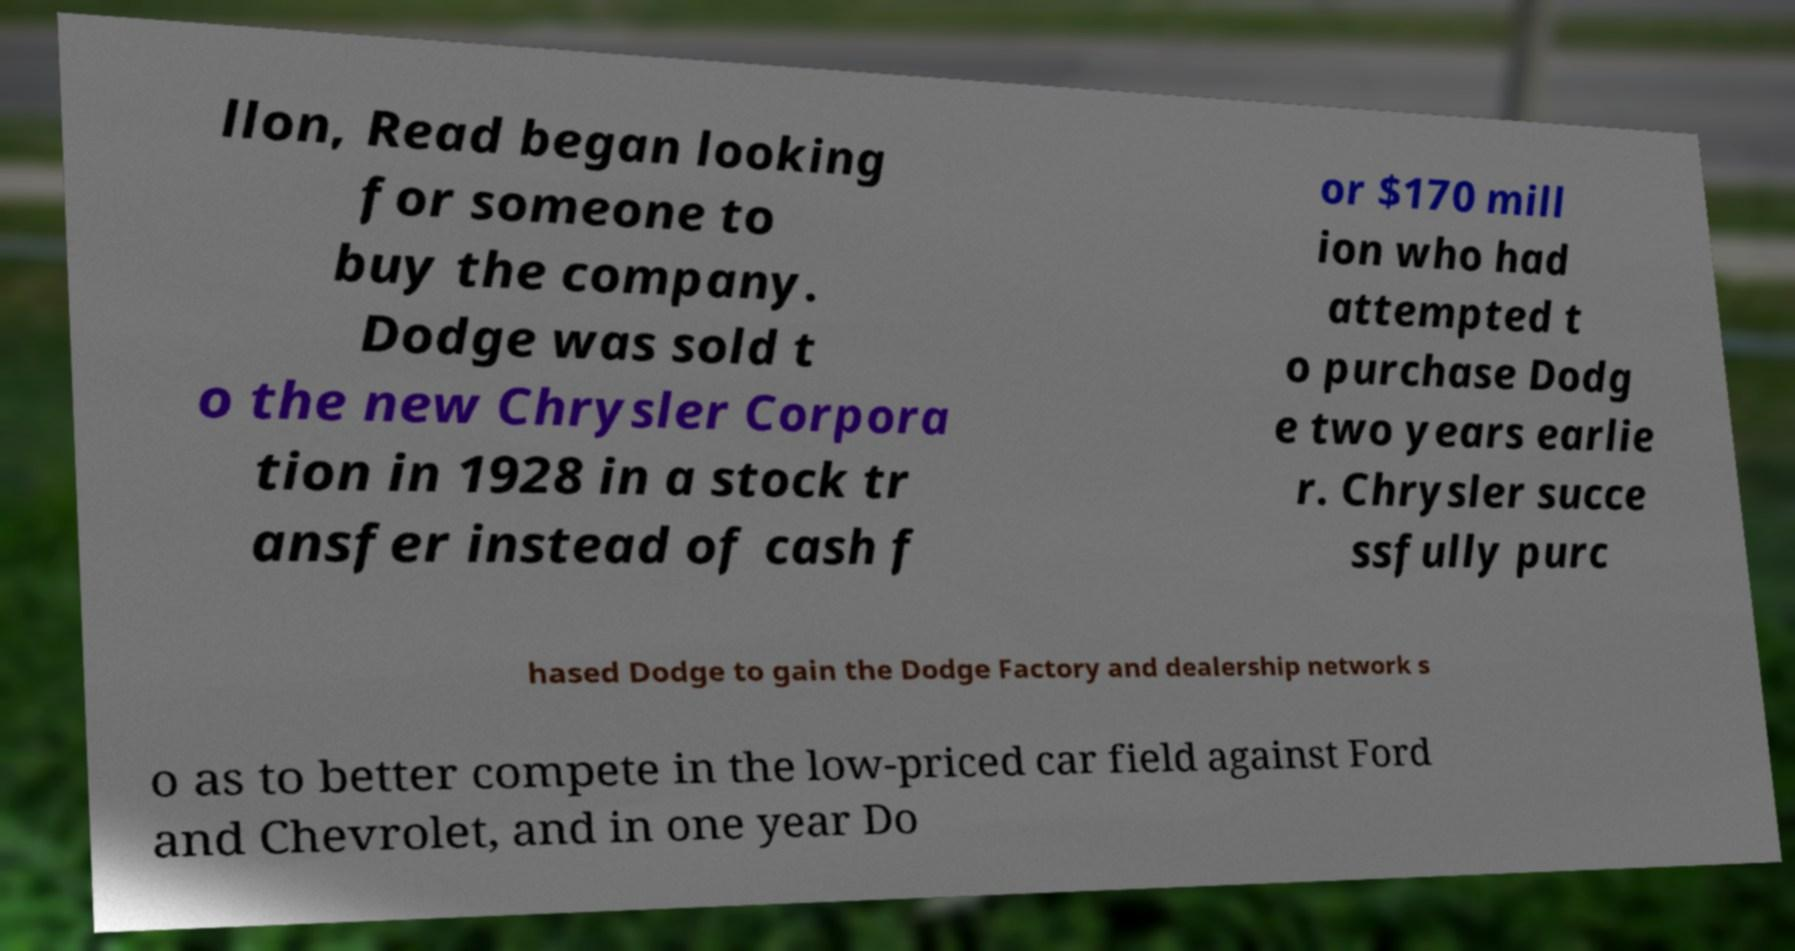Please identify and transcribe the text found in this image. llon, Read began looking for someone to buy the company. Dodge was sold t o the new Chrysler Corpora tion in 1928 in a stock tr ansfer instead of cash f or $170 mill ion who had attempted t o purchase Dodg e two years earlie r. Chrysler succe ssfully purc hased Dodge to gain the Dodge Factory and dealership network s o as to better compete in the low-priced car field against Ford and Chevrolet, and in one year Do 